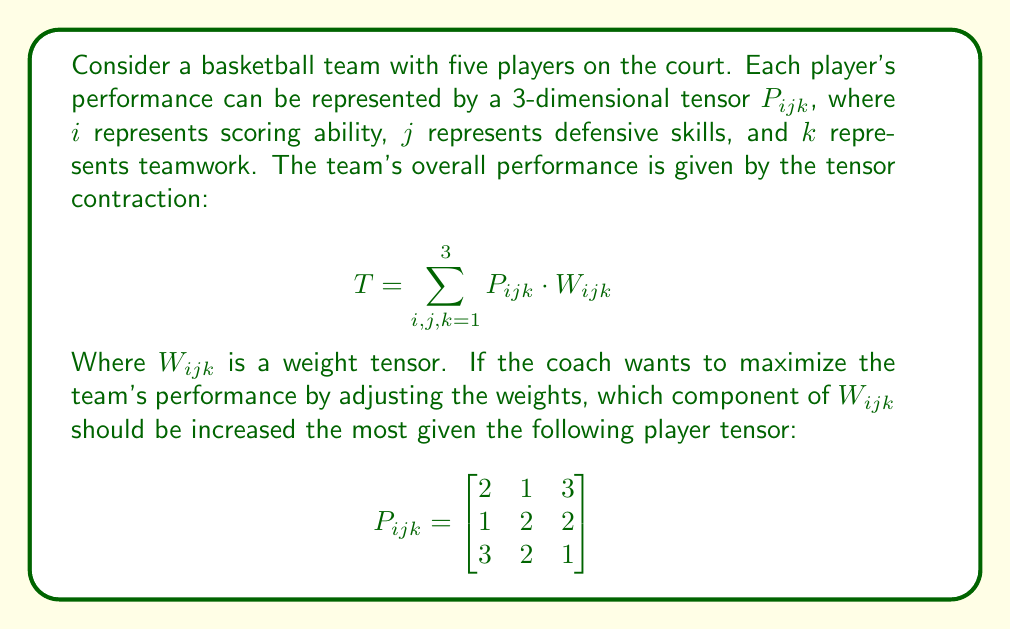What is the answer to this math problem? To determine which component of $W_{ijk}$ should be increased the most, we need to identify the largest value in the player tensor $P_{ijk}$. This is because increasing the corresponding weight will have the greatest impact on the overall team performance $T$.

Let's analyze the given player tensor:

$$P_{ijk} = \begin{bmatrix}
2 & 1 & 3 \\
1 & 2 & 2 \\
3 & 2 & 1
\end{bmatrix}$$

Step 1: Identify the largest value in $P_{ijk}$.
The largest value in $P_{ijk}$ is 3, which appears twice:
- At position (1,3): $P_{113} = 3$
- At position (3,1): $P_{311} = 3$

Step 2: Interpret the tensor components.
- $P_{113} = 3$ represents high scoring ability (i=1) and teamwork (k=3) with low defensive skills (j=1).
- $P_{311} = 3$ represents high teamwork (i=3) and scoring ability (k=1) with low defensive skills (j=1).

Step 3: Choose the most relevant component for a basketball team.
As a former basketball coach, we know that a combination of high scoring ability and teamwork is generally more valuable than high teamwork and scoring ability alone. Therefore, we should focus on $P_{113}$.

Step 4: Determine the corresponding weight component.
The weight component that corresponds to $P_{113}$ is $W_{113}$.

Therefore, to maximize the team's performance, the coach should increase $W_{113}$ the most, as this will capitalize on the players' strengths in scoring ability and teamwork.
Answer: $W_{113}$ 